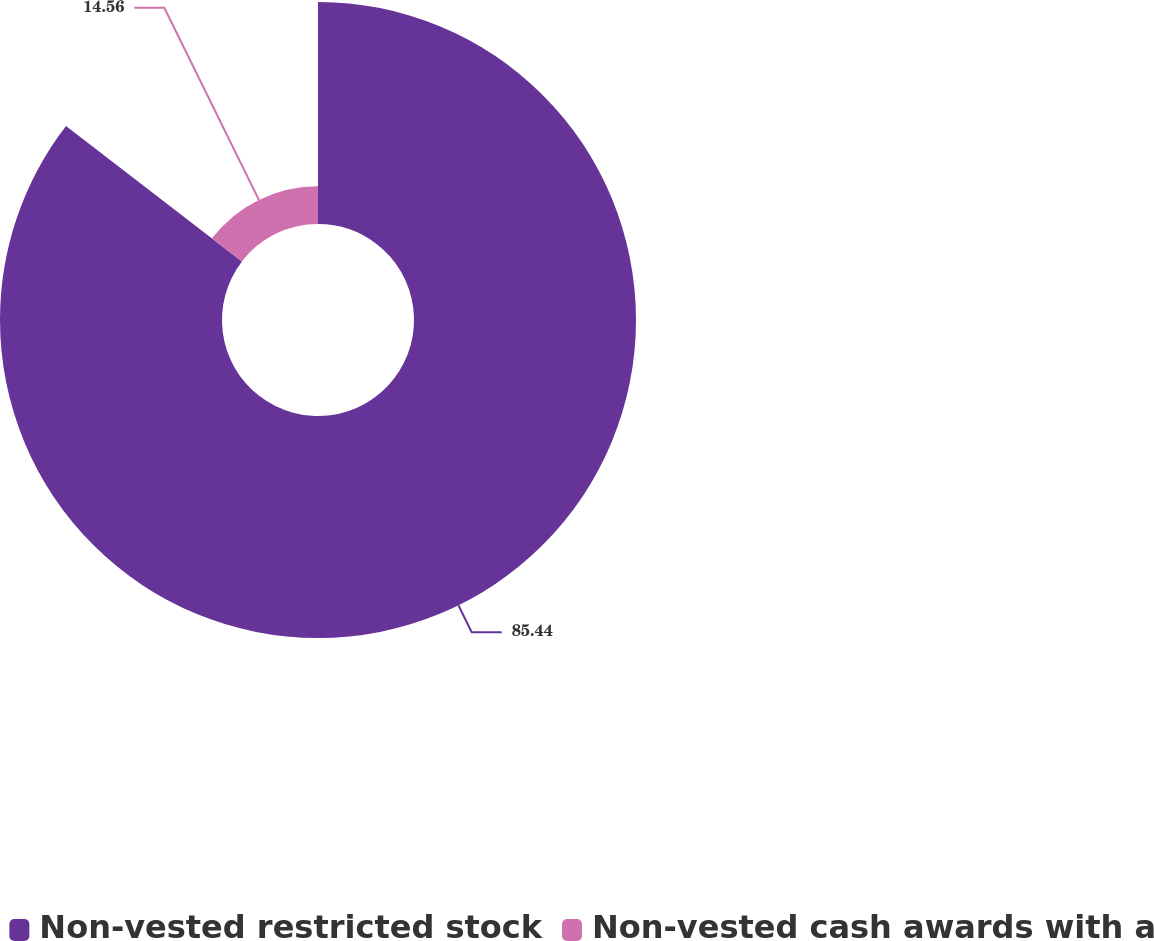Convert chart to OTSL. <chart><loc_0><loc_0><loc_500><loc_500><pie_chart><fcel>Non-vested restricted stock<fcel>Non-vested cash awards with a<nl><fcel>85.44%<fcel>14.56%<nl></chart> 